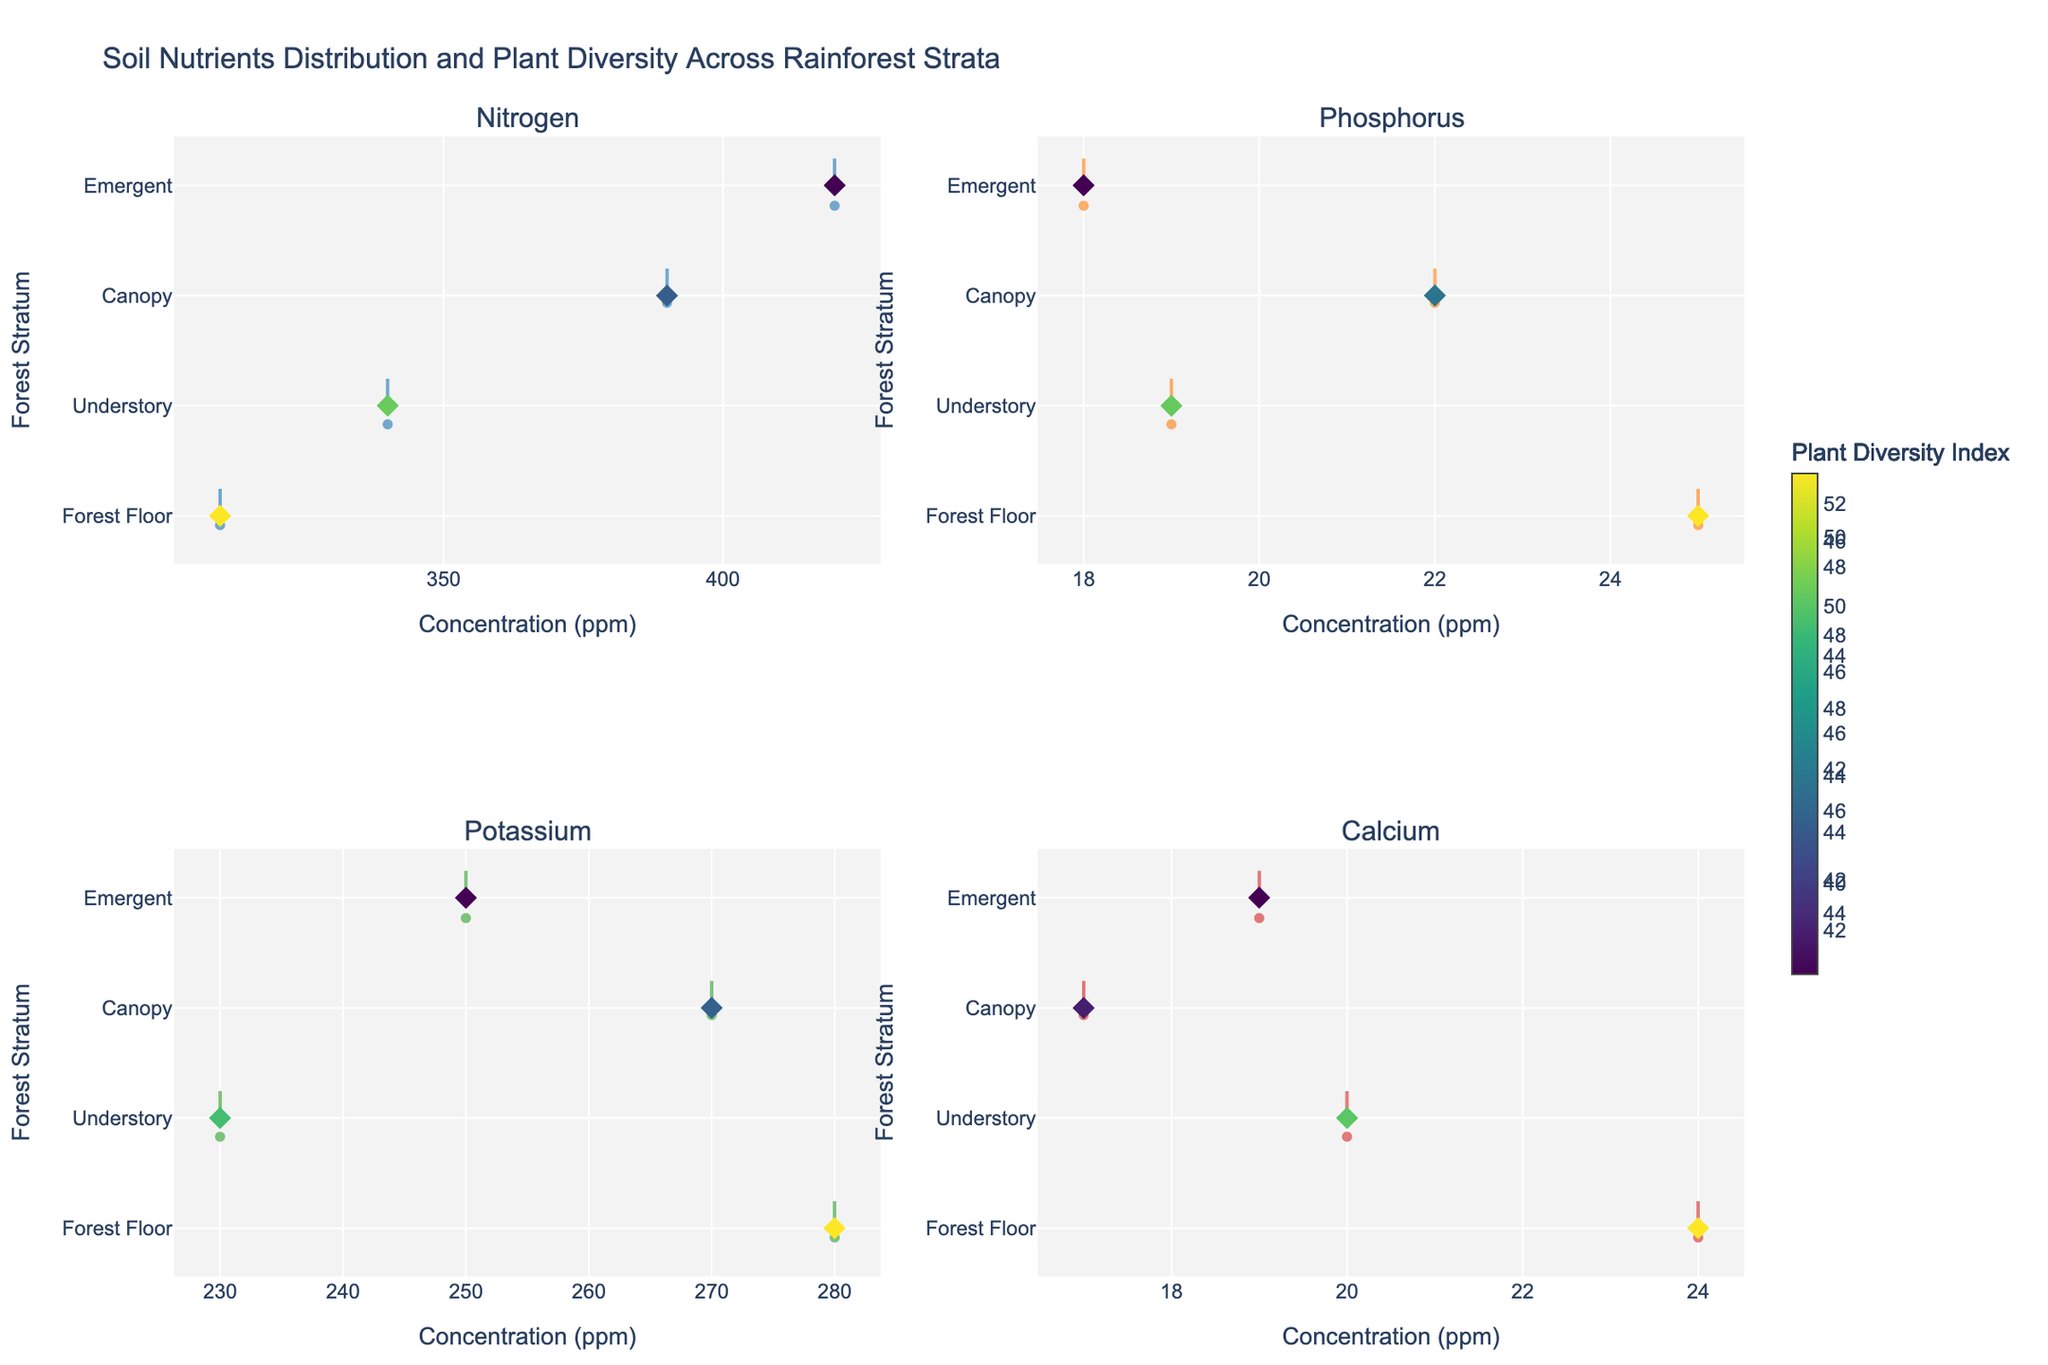What forest stratum has the highest concentration of nitrogen? By looking at the horizontal violin plots in the subplot for nitrogen, we can see which stratum has the peak concentration at the rightmost side.
Answer: Emergent Which soil nutrient shows the highest concentration in the Forest Floor stratum? We need to look at the different subplots and identify which nutrient has the highest value among the Forest Floor data points.
Answer: Potassium What is the range of phosphorus concentrations across all strata? We need to observe the horizontal spread of the phosphorus violin plot from lowest to highest concentration.
Answer: 18-25 ppm How does the average plant diversity index compare between the Canopy and Understory for nitrogen? Check the scatter points corresponding to nitrogen for both the Canopy and Understory, average their plant diversity indices, and then compare.
Answer: Understory is higher Which stratum has the widest variation in calcium concentration? By comparing the width of the horizontal violin plots for calcium across all strata, we can determine which stratum has the greatest spread.
Answer: Forest Floor What is the relationship between potassium concentration and plant diversity index in the Emergent stratum? Observing the positioning and color gradient of the scatter points for potassium in the Emergent stratum helps understand this relationship.
Answer: Higher potassium is associated with higher diversity Compare the median nitrogen concentration between the Canopy and Forest Floor strata. Check the position of the meanline within the nitrogen violin plots of both strata and compare their central tendency.
Answer: Canopy is higher Which nutrient shows the least variation in concentration among the Forest Floor, as evident from the violin plots? The narrowest horizontal violin plot among the nutrients for Forest Floor indicates the least variation.
Answer: Calcium Is there a strong correlation between phosphorus concentration and plant diversity index in the Understory? Examine if the color gradient and scatter points for phosphorus in the Understory stratum show a consistent pattern.
Answer: No strong correlation How does the plant diversity index in the Canopy compare to the Forest Floor for calcium? By analyzing the scatter point colors in the calcium subplot for both strata, we can compare the plant diversity indices.
Answer: Forest Floor is higher 